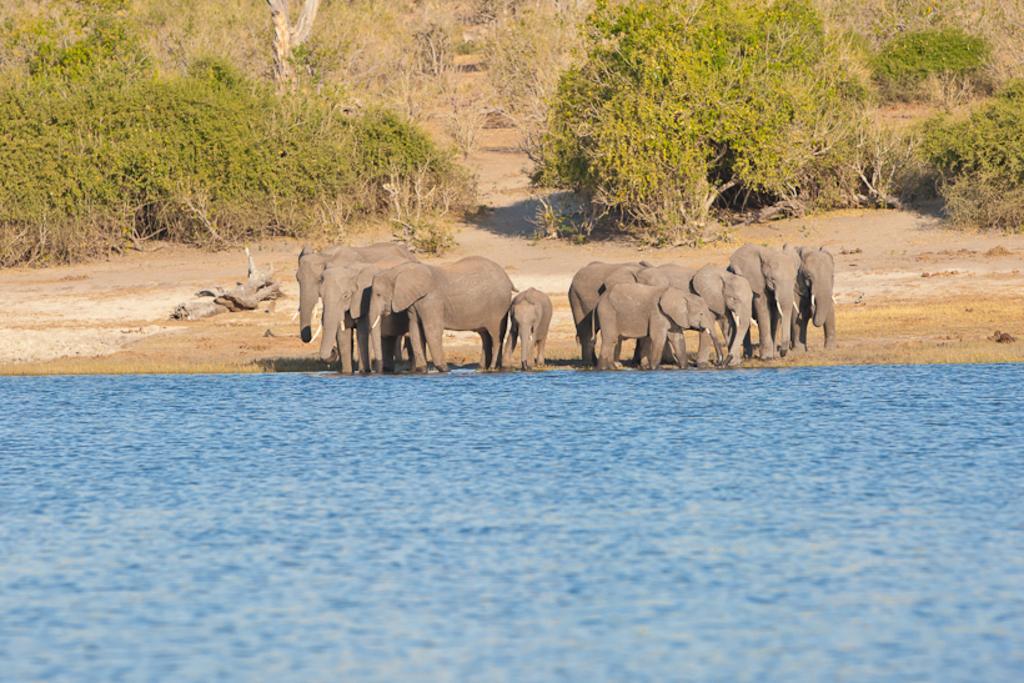Describe this image in one or two sentences. In this picture we can see a lake and a herd of elephants. Behind the elephants there are trees. 